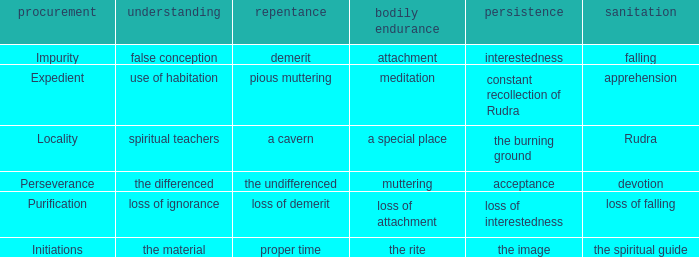 what's the permanence of the body where penance is the undifferenced Muttering. 